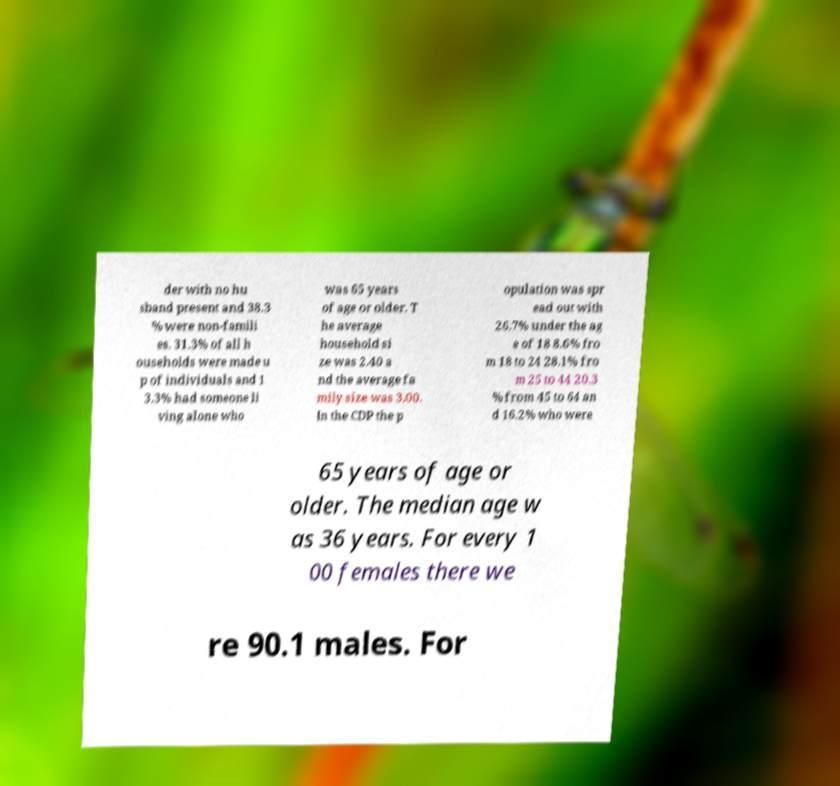Can you read and provide the text displayed in the image?This photo seems to have some interesting text. Can you extract and type it out for me? der with no hu sband present and 38.3 % were non-famili es. 31.3% of all h ouseholds were made u p of individuals and 1 3.3% had someone li ving alone who was 65 years of age or older. T he average household si ze was 2.40 a nd the average fa mily size was 3.00. In the CDP the p opulation was spr ead out with 26.7% under the ag e of 18 8.6% fro m 18 to 24 28.1% fro m 25 to 44 20.3 % from 45 to 64 an d 16.2% who were 65 years of age or older. The median age w as 36 years. For every 1 00 females there we re 90.1 males. For 